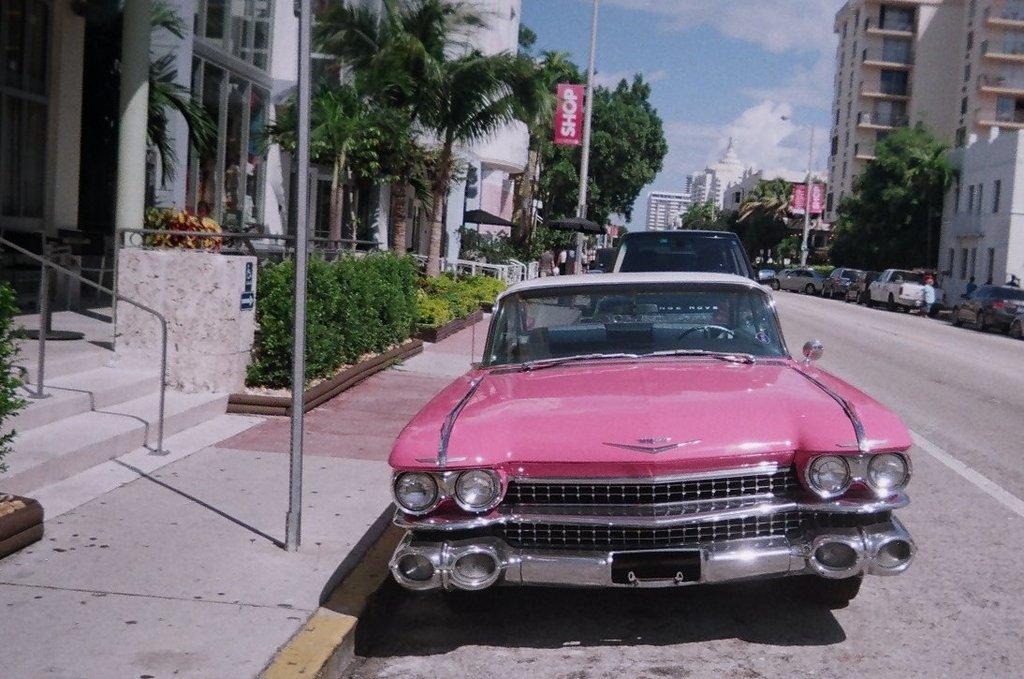In one or two sentences, can you explain what this image depicts? In this image I can see cars on the road. There are poles, trees and buildings on the either sides of the road. There is sky at the top. 